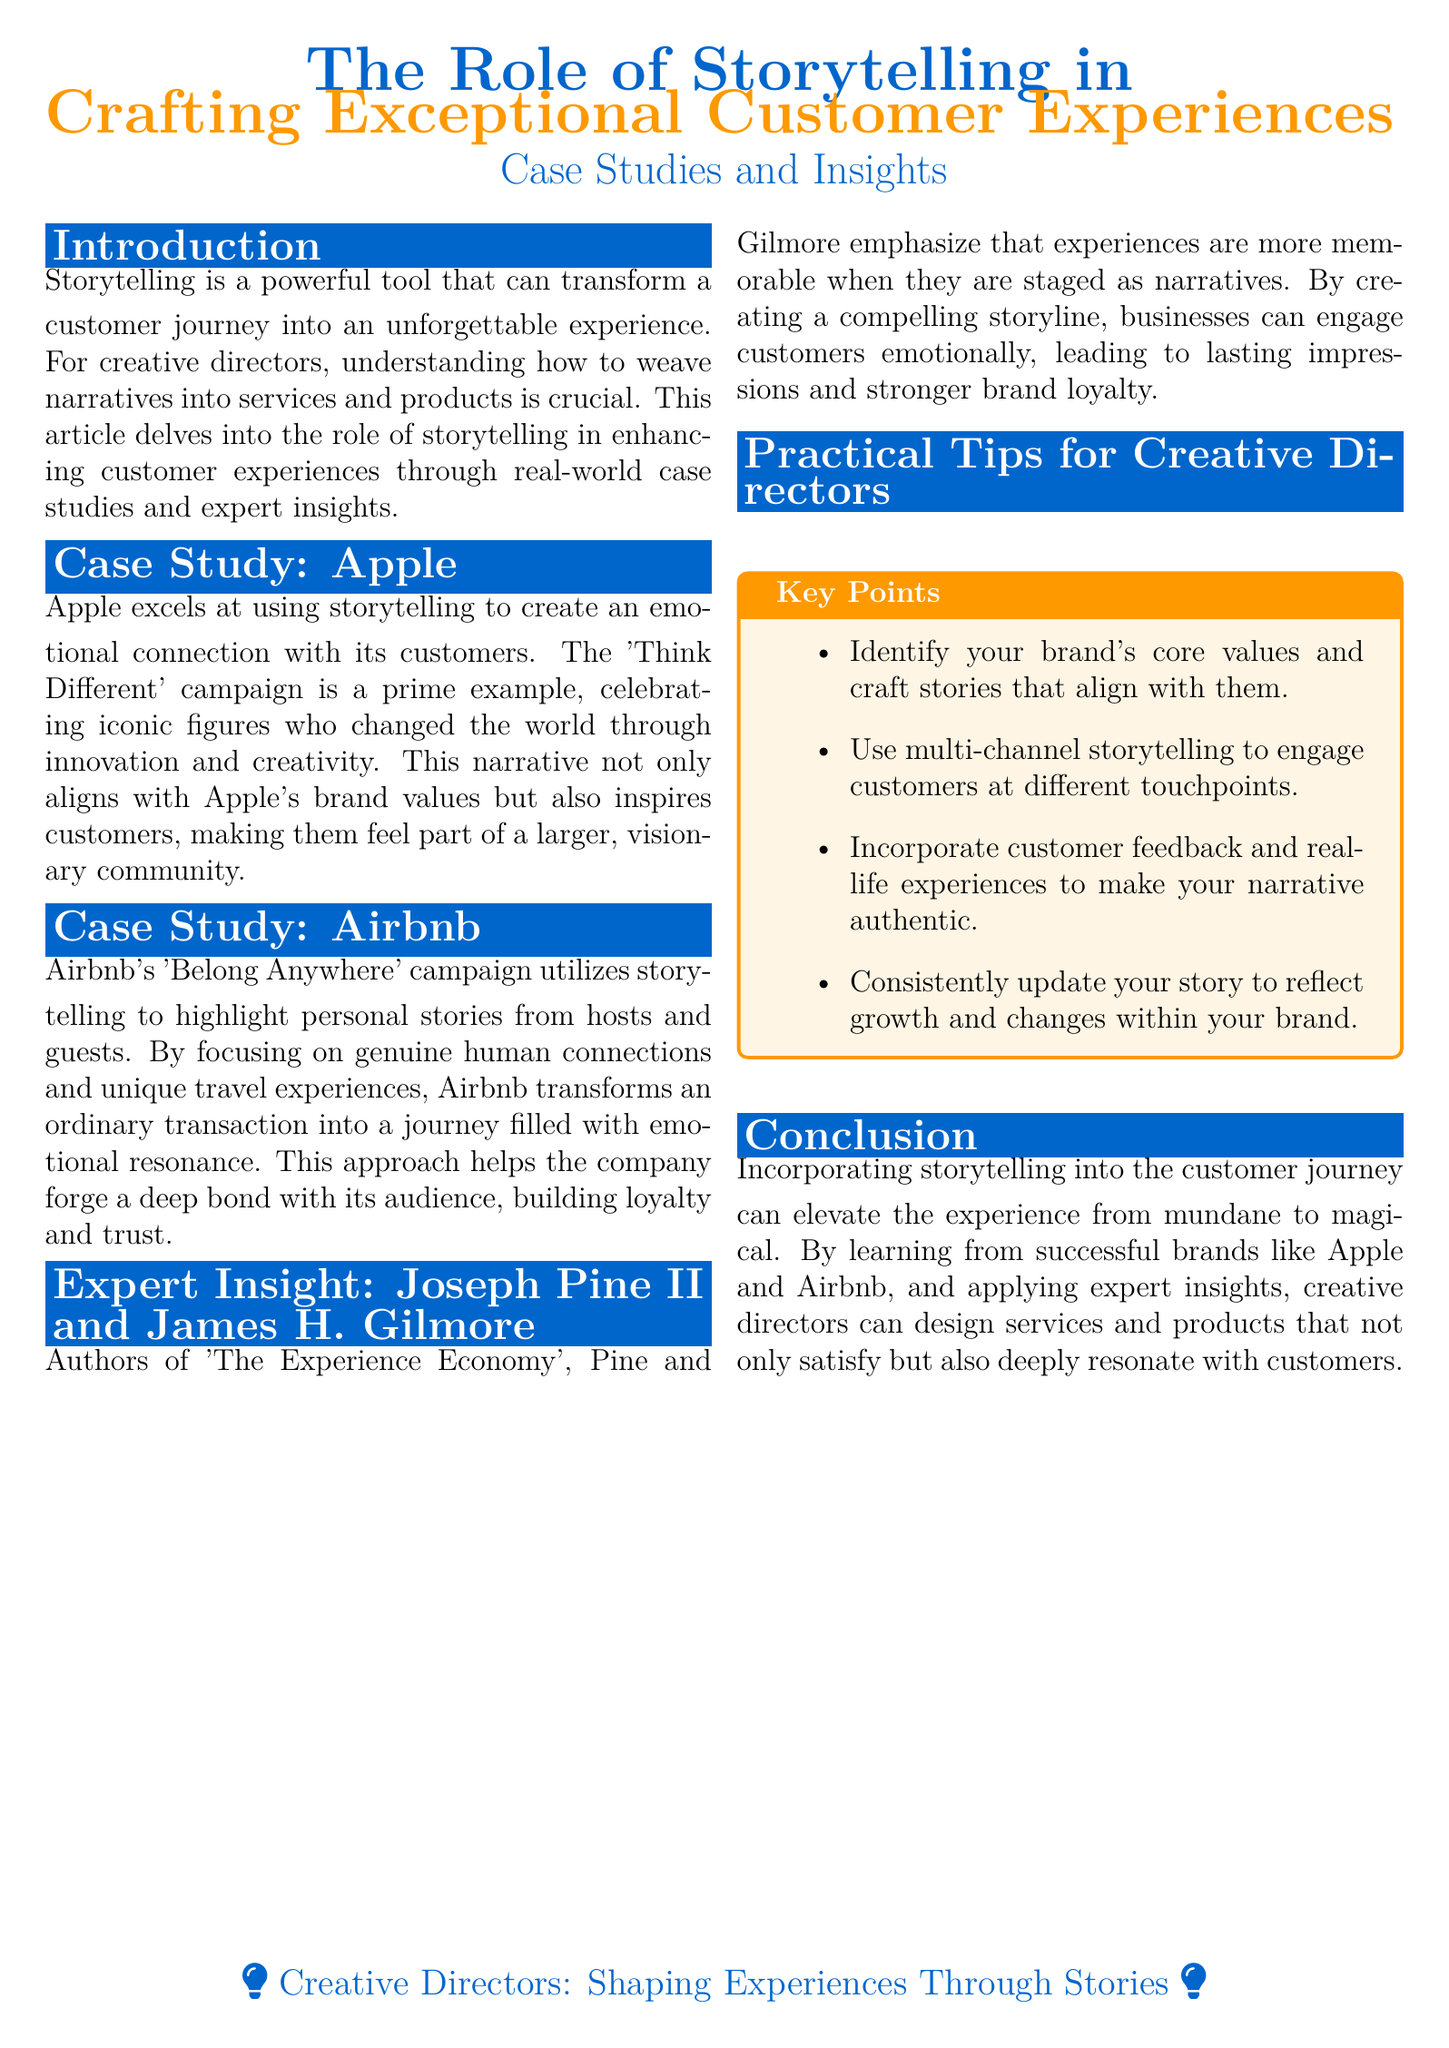What is the main topic of the article? The main topic is stated in the title, which focuses on storytelling and its role in enhancing customer experiences.
Answer: The Role of Storytelling in Crafting Exceptional Customer Experiences Which company is mentioned in relation to the 'Think Different' campaign? The 'Think Different' campaign is explicitly associated with Apple within the document.
Answer: Apple What emotional connection does Airbnb aim to create? The document states that Airbnb focuses on highlighting personal stories, aiming to create genuine human connections.
Answer: Genuine human connections Who are the authors referenced in the expert insight section? The expert insight section mentions specific authors known for their work related to customer experiences.
Answer: Joseph Pine II and James H. Gilmore Which branding campaign is associated with Airbnb? The specific campaign discussed in relation to Airbnb is clearly mentioned in the document.
Answer: 'Belong Anywhere' What is one key point for creative directors? The practical tips section includes several points; one can be highlighted as a specific directive.
Answer: Identify your brand's core values How does storytelling affect customer experiences according to the conclusion? The conclusion summarizes storytelling's impact on customer experiences as described in the document.
Answer: Elevate the experience from mundane to magical What type of document is this? The structure and layout, along with the focus on case studies and insights, indicate the type of document.
Answer: Magazine layout 